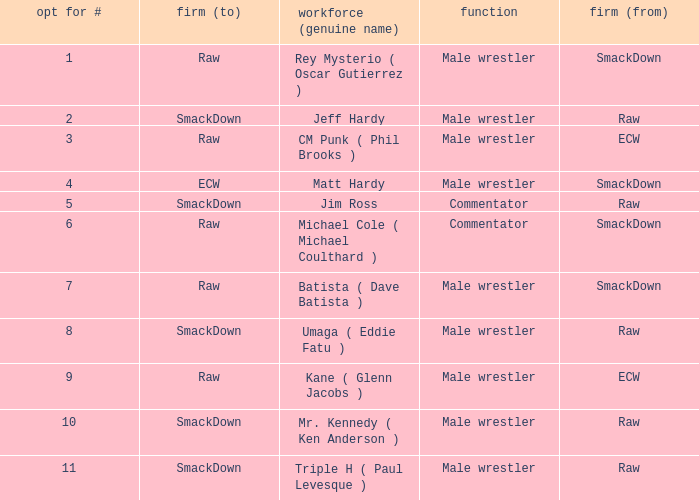What is the real name of the Pick # that is greater than 9? Mr. Kennedy ( Ken Anderson ), Triple H ( Paul Levesque ). Give me the full table as a dictionary. {'header': ['opt for #', 'firm (to)', 'workforce (genuine name)', 'function', 'firm (from)'], 'rows': [['1', 'Raw', 'Rey Mysterio ( Oscar Gutierrez )', 'Male wrestler', 'SmackDown'], ['2', 'SmackDown', 'Jeff Hardy', 'Male wrestler', 'Raw'], ['3', 'Raw', 'CM Punk ( Phil Brooks )', 'Male wrestler', 'ECW'], ['4', 'ECW', 'Matt Hardy', 'Male wrestler', 'SmackDown'], ['5', 'SmackDown', 'Jim Ross', 'Commentator', 'Raw'], ['6', 'Raw', 'Michael Cole ( Michael Coulthard )', 'Commentator', 'SmackDown'], ['7', 'Raw', 'Batista ( Dave Batista )', 'Male wrestler', 'SmackDown'], ['8', 'SmackDown', 'Umaga ( Eddie Fatu )', 'Male wrestler', 'Raw'], ['9', 'Raw', 'Kane ( Glenn Jacobs )', 'Male wrestler', 'ECW'], ['10', 'SmackDown', 'Mr. Kennedy ( Ken Anderson )', 'Male wrestler', 'Raw'], ['11', 'SmackDown', 'Triple H ( Paul Levesque )', 'Male wrestler', 'Raw']]} 